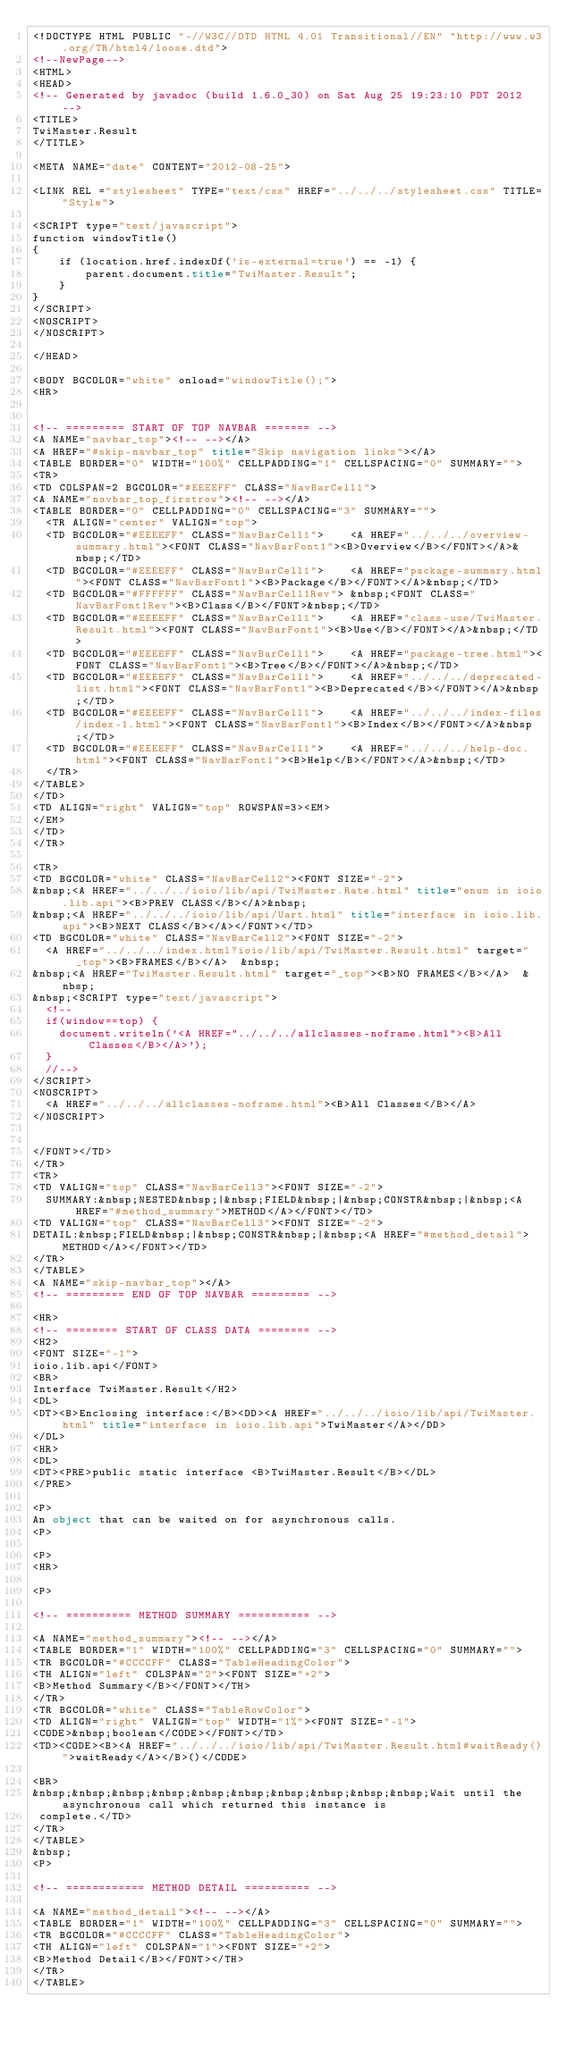Convert code to text. <code><loc_0><loc_0><loc_500><loc_500><_HTML_><!DOCTYPE HTML PUBLIC "-//W3C//DTD HTML 4.01 Transitional//EN" "http://www.w3.org/TR/html4/loose.dtd">
<!--NewPage-->
<HTML>
<HEAD>
<!-- Generated by javadoc (build 1.6.0_30) on Sat Aug 25 19:23:10 PDT 2012 -->
<TITLE>
TwiMaster.Result
</TITLE>

<META NAME="date" CONTENT="2012-08-25">

<LINK REL ="stylesheet" TYPE="text/css" HREF="../../../stylesheet.css" TITLE="Style">

<SCRIPT type="text/javascript">
function windowTitle()
{
    if (location.href.indexOf('is-external=true') == -1) {
        parent.document.title="TwiMaster.Result";
    }
}
</SCRIPT>
<NOSCRIPT>
</NOSCRIPT>

</HEAD>

<BODY BGCOLOR="white" onload="windowTitle();">
<HR>


<!-- ========= START OF TOP NAVBAR ======= -->
<A NAME="navbar_top"><!-- --></A>
<A HREF="#skip-navbar_top" title="Skip navigation links"></A>
<TABLE BORDER="0" WIDTH="100%" CELLPADDING="1" CELLSPACING="0" SUMMARY="">
<TR>
<TD COLSPAN=2 BGCOLOR="#EEEEFF" CLASS="NavBarCell1">
<A NAME="navbar_top_firstrow"><!-- --></A>
<TABLE BORDER="0" CELLPADDING="0" CELLSPACING="3" SUMMARY="">
  <TR ALIGN="center" VALIGN="top">
  <TD BGCOLOR="#EEEEFF" CLASS="NavBarCell1">    <A HREF="../../../overview-summary.html"><FONT CLASS="NavBarFont1"><B>Overview</B></FONT></A>&nbsp;</TD>
  <TD BGCOLOR="#EEEEFF" CLASS="NavBarCell1">    <A HREF="package-summary.html"><FONT CLASS="NavBarFont1"><B>Package</B></FONT></A>&nbsp;</TD>
  <TD BGCOLOR="#FFFFFF" CLASS="NavBarCell1Rev"> &nbsp;<FONT CLASS="NavBarFont1Rev"><B>Class</B></FONT>&nbsp;</TD>
  <TD BGCOLOR="#EEEEFF" CLASS="NavBarCell1">    <A HREF="class-use/TwiMaster.Result.html"><FONT CLASS="NavBarFont1"><B>Use</B></FONT></A>&nbsp;</TD>
  <TD BGCOLOR="#EEEEFF" CLASS="NavBarCell1">    <A HREF="package-tree.html"><FONT CLASS="NavBarFont1"><B>Tree</B></FONT></A>&nbsp;</TD>
  <TD BGCOLOR="#EEEEFF" CLASS="NavBarCell1">    <A HREF="../../../deprecated-list.html"><FONT CLASS="NavBarFont1"><B>Deprecated</B></FONT></A>&nbsp;</TD>
  <TD BGCOLOR="#EEEEFF" CLASS="NavBarCell1">    <A HREF="../../../index-files/index-1.html"><FONT CLASS="NavBarFont1"><B>Index</B></FONT></A>&nbsp;</TD>
  <TD BGCOLOR="#EEEEFF" CLASS="NavBarCell1">    <A HREF="../../../help-doc.html"><FONT CLASS="NavBarFont1"><B>Help</B></FONT></A>&nbsp;</TD>
  </TR>
</TABLE>
</TD>
<TD ALIGN="right" VALIGN="top" ROWSPAN=3><EM>
</EM>
</TD>
</TR>

<TR>
<TD BGCOLOR="white" CLASS="NavBarCell2"><FONT SIZE="-2">
&nbsp;<A HREF="../../../ioio/lib/api/TwiMaster.Rate.html" title="enum in ioio.lib.api"><B>PREV CLASS</B></A>&nbsp;
&nbsp;<A HREF="../../../ioio/lib/api/Uart.html" title="interface in ioio.lib.api"><B>NEXT CLASS</B></A></FONT></TD>
<TD BGCOLOR="white" CLASS="NavBarCell2"><FONT SIZE="-2">
  <A HREF="../../../index.html?ioio/lib/api/TwiMaster.Result.html" target="_top"><B>FRAMES</B></A>  &nbsp;
&nbsp;<A HREF="TwiMaster.Result.html" target="_top"><B>NO FRAMES</B></A>  &nbsp;
&nbsp;<SCRIPT type="text/javascript">
  <!--
  if(window==top) {
    document.writeln('<A HREF="../../../allclasses-noframe.html"><B>All Classes</B></A>');
  }
  //-->
</SCRIPT>
<NOSCRIPT>
  <A HREF="../../../allclasses-noframe.html"><B>All Classes</B></A>
</NOSCRIPT>


</FONT></TD>
</TR>
<TR>
<TD VALIGN="top" CLASS="NavBarCell3"><FONT SIZE="-2">
  SUMMARY:&nbsp;NESTED&nbsp;|&nbsp;FIELD&nbsp;|&nbsp;CONSTR&nbsp;|&nbsp;<A HREF="#method_summary">METHOD</A></FONT></TD>
<TD VALIGN="top" CLASS="NavBarCell3"><FONT SIZE="-2">
DETAIL:&nbsp;FIELD&nbsp;|&nbsp;CONSTR&nbsp;|&nbsp;<A HREF="#method_detail">METHOD</A></FONT></TD>
</TR>
</TABLE>
<A NAME="skip-navbar_top"></A>
<!-- ========= END OF TOP NAVBAR ========= -->

<HR>
<!-- ======== START OF CLASS DATA ======== -->
<H2>
<FONT SIZE="-1">
ioio.lib.api</FONT>
<BR>
Interface TwiMaster.Result</H2>
<DL>
<DT><B>Enclosing interface:</B><DD><A HREF="../../../ioio/lib/api/TwiMaster.html" title="interface in ioio.lib.api">TwiMaster</A></DD>
</DL>
<HR>
<DL>
<DT><PRE>public static interface <B>TwiMaster.Result</B></DL>
</PRE>

<P>
An object that can be waited on for asynchronous calls.
<P>

<P>
<HR>

<P>

<!-- ========== METHOD SUMMARY =========== -->

<A NAME="method_summary"><!-- --></A>
<TABLE BORDER="1" WIDTH="100%" CELLPADDING="3" CELLSPACING="0" SUMMARY="">
<TR BGCOLOR="#CCCCFF" CLASS="TableHeadingColor">
<TH ALIGN="left" COLSPAN="2"><FONT SIZE="+2">
<B>Method Summary</B></FONT></TH>
</TR>
<TR BGCOLOR="white" CLASS="TableRowColor">
<TD ALIGN="right" VALIGN="top" WIDTH="1%"><FONT SIZE="-1">
<CODE>&nbsp;boolean</CODE></FONT></TD>
<TD><CODE><B><A HREF="../../../ioio/lib/api/TwiMaster.Result.html#waitReady()">waitReady</A></B>()</CODE>

<BR>
&nbsp;&nbsp;&nbsp;&nbsp;&nbsp;&nbsp;&nbsp;&nbsp;&nbsp;&nbsp;Wait until the asynchronous call which returned this instance is
 complete.</TD>
</TR>
</TABLE>
&nbsp;
<P>

<!-- ============ METHOD DETAIL ========== -->

<A NAME="method_detail"><!-- --></A>
<TABLE BORDER="1" WIDTH="100%" CELLPADDING="3" CELLSPACING="0" SUMMARY="">
<TR BGCOLOR="#CCCCFF" CLASS="TableHeadingColor">
<TH ALIGN="left" COLSPAN="1"><FONT SIZE="+2">
<B>Method Detail</B></FONT></TH>
</TR>
</TABLE>
</code> 